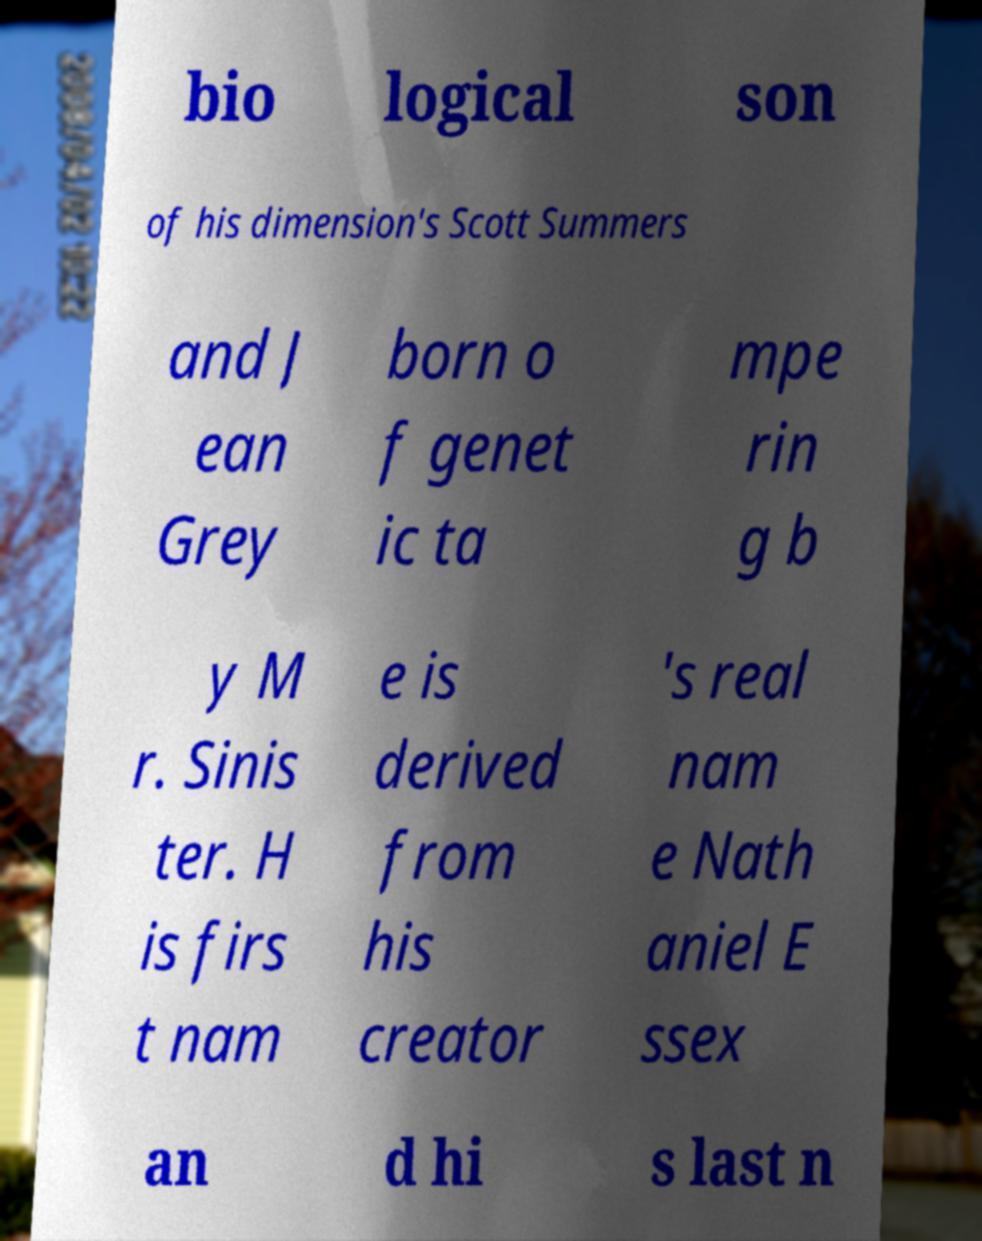Please read and relay the text visible in this image. What does it say? bio logical son of his dimension's Scott Summers and J ean Grey born o f genet ic ta mpe rin g b y M r. Sinis ter. H is firs t nam e is derived from his creator 's real nam e Nath aniel E ssex an d hi s last n 